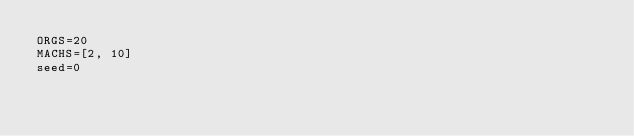Convert code to text. <code><loc_0><loc_0><loc_500><loc_500><_Python_>ORGS=20
MACHS=[2, 10]
seed=0</code> 